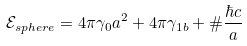<formula> <loc_0><loc_0><loc_500><loc_500>\mathcal { E } _ { s p h e r e } = 4 \pi \gamma _ { 0 } a ^ { 2 } + 4 \pi \gamma _ { 1 b } + \# \frac { \hbar { c } } { a }</formula> 